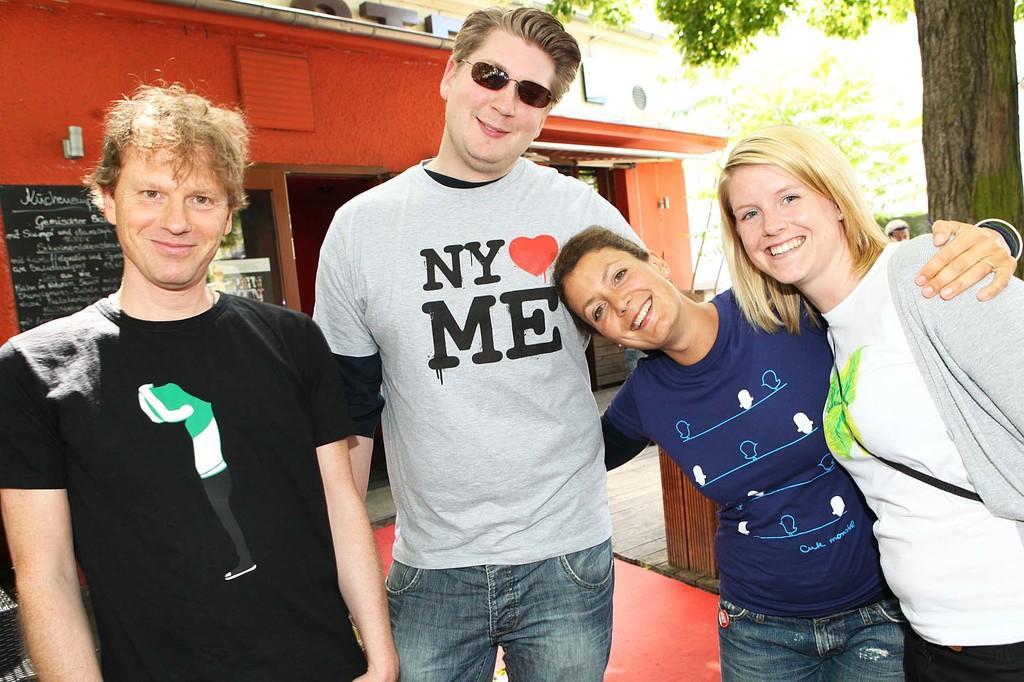How would you summarize this image in a sentence or two? In this picture we can see four people, they are smiling and in the background we can see a house, name board, posters, person and trees. 